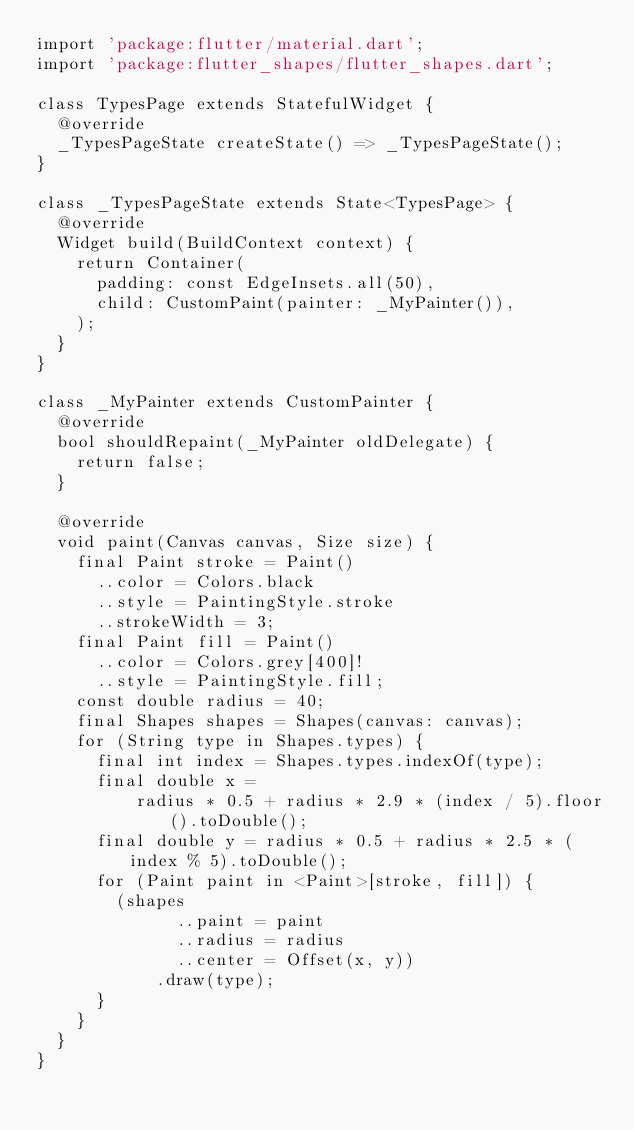<code> <loc_0><loc_0><loc_500><loc_500><_Dart_>import 'package:flutter/material.dart';
import 'package:flutter_shapes/flutter_shapes.dart';

class TypesPage extends StatefulWidget {
  @override
  _TypesPageState createState() => _TypesPageState();
}

class _TypesPageState extends State<TypesPage> {
  @override
  Widget build(BuildContext context) {
    return Container(
      padding: const EdgeInsets.all(50),
      child: CustomPaint(painter: _MyPainter()),
    );
  }
}

class _MyPainter extends CustomPainter {
  @override
  bool shouldRepaint(_MyPainter oldDelegate) {
    return false;
  }

  @override
  void paint(Canvas canvas, Size size) {
    final Paint stroke = Paint()
      ..color = Colors.black
      ..style = PaintingStyle.stroke
      ..strokeWidth = 3;
    final Paint fill = Paint()
      ..color = Colors.grey[400]!
      ..style = PaintingStyle.fill;
    const double radius = 40;
    final Shapes shapes = Shapes(canvas: canvas);
    for (String type in Shapes.types) {
      final int index = Shapes.types.indexOf(type);
      final double x =
          radius * 0.5 + radius * 2.9 * (index / 5).floor().toDouble();
      final double y = radius * 0.5 + radius * 2.5 * (index % 5).toDouble();
      for (Paint paint in <Paint>[stroke, fill]) {
        (shapes
              ..paint = paint
              ..radius = radius
              ..center = Offset(x, y))
            .draw(type);
      }
    }
  }
}
</code> 